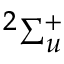Convert formula to latex. <formula><loc_0><loc_0><loc_500><loc_500>^ { 2 } \Sigma _ { u } ^ { + }</formula> 